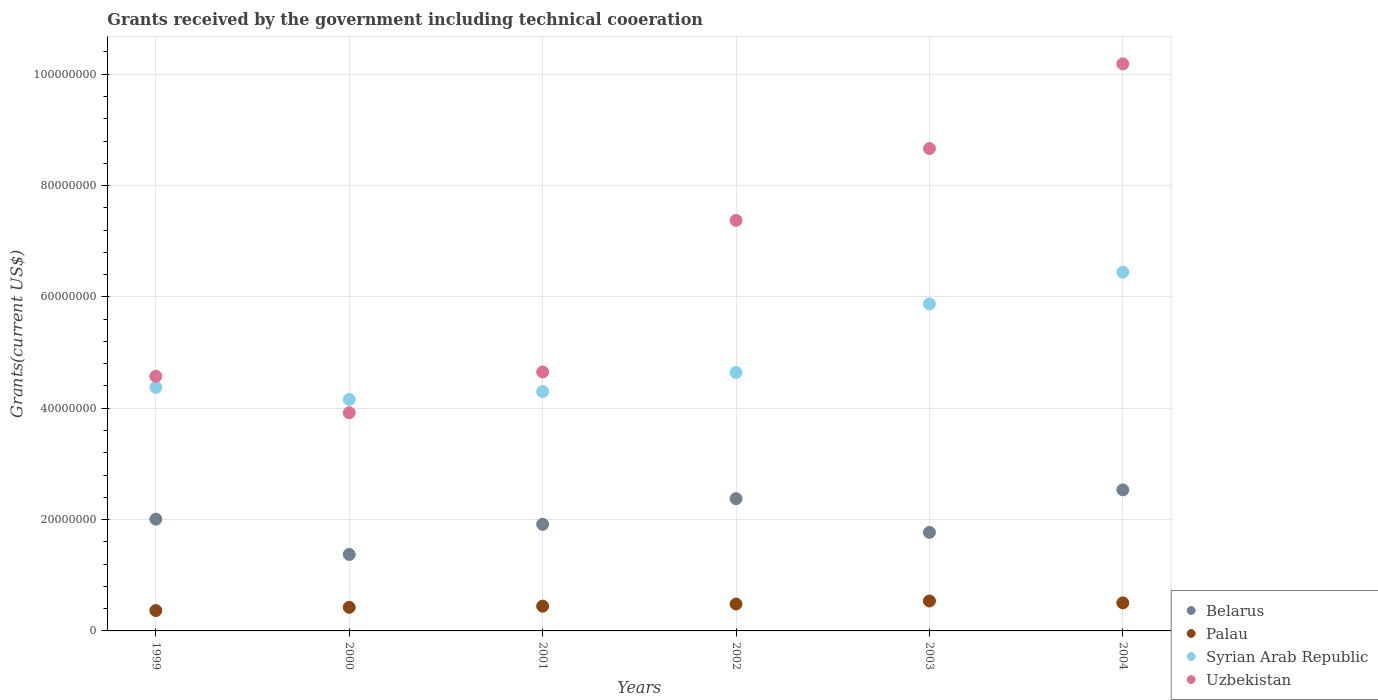How many different coloured dotlines are there?
Offer a terse response. 4. Is the number of dotlines equal to the number of legend labels?
Keep it short and to the point. Yes. What is the total grants received by the government in Belarus in 2003?
Offer a very short reply. 1.77e+07. Across all years, what is the maximum total grants received by the government in Palau?
Ensure brevity in your answer.  5.38e+06. Across all years, what is the minimum total grants received by the government in Syrian Arab Republic?
Provide a succinct answer. 4.16e+07. In which year was the total grants received by the government in Uzbekistan maximum?
Offer a terse response. 2004. In which year was the total grants received by the government in Syrian Arab Republic minimum?
Make the answer very short. 2000. What is the total total grants received by the government in Belarus in the graph?
Offer a terse response. 1.20e+08. What is the difference between the total grants received by the government in Syrian Arab Republic in 1999 and that in 2001?
Keep it short and to the point. 7.60e+05. What is the difference between the total grants received by the government in Syrian Arab Republic in 2003 and the total grants received by the government in Uzbekistan in 1999?
Your answer should be compact. 1.30e+07. What is the average total grants received by the government in Palau per year?
Your answer should be very brief. 4.60e+06. In the year 2001, what is the difference between the total grants received by the government in Belarus and total grants received by the government in Syrian Arab Republic?
Your answer should be very brief. -2.38e+07. In how many years, is the total grants received by the government in Belarus greater than 92000000 US$?
Your answer should be very brief. 0. What is the ratio of the total grants received by the government in Uzbekistan in 2001 to that in 2004?
Offer a terse response. 0.46. Is the total grants received by the government in Syrian Arab Republic in 2001 less than that in 2004?
Give a very brief answer. Yes. What is the difference between the highest and the lowest total grants received by the government in Uzbekistan?
Give a very brief answer. 6.27e+07. In how many years, is the total grants received by the government in Palau greater than the average total grants received by the government in Palau taken over all years?
Your answer should be compact. 3. Is the sum of the total grants received by the government in Belarus in 2001 and 2003 greater than the maximum total grants received by the government in Syrian Arab Republic across all years?
Your response must be concise. No. Is it the case that in every year, the sum of the total grants received by the government in Palau and total grants received by the government in Uzbekistan  is greater than the sum of total grants received by the government in Belarus and total grants received by the government in Syrian Arab Republic?
Keep it short and to the point. No. Is it the case that in every year, the sum of the total grants received by the government in Palau and total grants received by the government in Uzbekistan  is greater than the total grants received by the government in Belarus?
Your response must be concise. Yes. Does the total grants received by the government in Syrian Arab Republic monotonically increase over the years?
Make the answer very short. No. Is the total grants received by the government in Uzbekistan strictly less than the total grants received by the government in Palau over the years?
Ensure brevity in your answer.  No. What is the difference between two consecutive major ticks on the Y-axis?
Make the answer very short. 2.00e+07. Does the graph contain grids?
Make the answer very short. Yes. How many legend labels are there?
Give a very brief answer. 4. How are the legend labels stacked?
Provide a short and direct response. Vertical. What is the title of the graph?
Offer a very short reply. Grants received by the government including technical cooeration. What is the label or title of the Y-axis?
Your response must be concise. Grants(current US$). What is the Grants(current US$) in Belarus in 1999?
Give a very brief answer. 2.01e+07. What is the Grants(current US$) of Palau in 1999?
Offer a very short reply. 3.66e+06. What is the Grants(current US$) of Syrian Arab Republic in 1999?
Offer a terse response. 4.38e+07. What is the Grants(current US$) in Uzbekistan in 1999?
Provide a short and direct response. 4.57e+07. What is the Grants(current US$) of Belarus in 2000?
Make the answer very short. 1.37e+07. What is the Grants(current US$) in Palau in 2000?
Offer a terse response. 4.24e+06. What is the Grants(current US$) of Syrian Arab Republic in 2000?
Give a very brief answer. 4.16e+07. What is the Grants(current US$) of Uzbekistan in 2000?
Provide a short and direct response. 3.92e+07. What is the Grants(current US$) in Belarus in 2001?
Offer a very short reply. 1.92e+07. What is the Grants(current US$) in Palau in 2001?
Offer a very short reply. 4.45e+06. What is the Grants(current US$) in Syrian Arab Republic in 2001?
Provide a succinct answer. 4.30e+07. What is the Grants(current US$) in Uzbekistan in 2001?
Ensure brevity in your answer.  4.65e+07. What is the Grants(current US$) of Belarus in 2002?
Offer a terse response. 2.38e+07. What is the Grants(current US$) of Palau in 2002?
Provide a short and direct response. 4.83e+06. What is the Grants(current US$) of Syrian Arab Republic in 2002?
Offer a very short reply. 4.64e+07. What is the Grants(current US$) in Uzbekistan in 2002?
Your response must be concise. 7.38e+07. What is the Grants(current US$) in Belarus in 2003?
Keep it short and to the point. 1.77e+07. What is the Grants(current US$) of Palau in 2003?
Give a very brief answer. 5.38e+06. What is the Grants(current US$) of Syrian Arab Republic in 2003?
Ensure brevity in your answer.  5.87e+07. What is the Grants(current US$) of Uzbekistan in 2003?
Provide a short and direct response. 8.66e+07. What is the Grants(current US$) in Belarus in 2004?
Your answer should be very brief. 2.53e+07. What is the Grants(current US$) of Palau in 2004?
Your answer should be very brief. 5.04e+06. What is the Grants(current US$) in Syrian Arab Republic in 2004?
Your response must be concise. 6.44e+07. What is the Grants(current US$) of Uzbekistan in 2004?
Your answer should be very brief. 1.02e+08. Across all years, what is the maximum Grants(current US$) in Belarus?
Give a very brief answer. 2.53e+07. Across all years, what is the maximum Grants(current US$) of Palau?
Make the answer very short. 5.38e+06. Across all years, what is the maximum Grants(current US$) in Syrian Arab Republic?
Your response must be concise. 6.44e+07. Across all years, what is the maximum Grants(current US$) in Uzbekistan?
Provide a short and direct response. 1.02e+08. Across all years, what is the minimum Grants(current US$) of Belarus?
Offer a terse response. 1.37e+07. Across all years, what is the minimum Grants(current US$) of Palau?
Give a very brief answer. 3.66e+06. Across all years, what is the minimum Grants(current US$) of Syrian Arab Republic?
Offer a terse response. 4.16e+07. Across all years, what is the minimum Grants(current US$) of Uzbekistan?
Offer a very short reply. 3.92e+07. What is the total Grants(current US$) in Belarus in the graph?
Your response must be concise. 1.20e+08. What is the total Grants(current US$) of Palau in the graph?
Keep it short and to the point. 2.76e+07. What is the total Grants(current US$) in Syrian Arab Republic in the graph?
Offer a terse response. 2.98e+08. What is the total Grants(current US$) in Uzbekistan in the graph?
Give a very brief answer. 3.94e+08. What is the difference between the Grants(current US$) of Belarus in 1999 and that in 2000?
Give a very brief answer. 6.34e+06. What is the difference between the Grants(current US$) of Palau in 1999 and that in 2000?
Your answer should be very brief. -5.80e+05. What is the difference between the Grants(current US$) in Syrian Arab Republic in 1999 and that in 2000?
Provide a short and direct response. 2.17e+06. What is the difference between the Grants(current US$) in Uzbekistan in 1999 and that in 2000?
Give a very brief answer. 6.55e+06. What is the difference between the Grants(current US$) in Belarus in 1999 and that in 2001?
Keep it short and to the point. 9.30e+05. What is the difference between the Grants(current US$) of Palau in 1999 and that in 2001?
Your response must be concise. -7.90e+05. What is the difference between the Grants(current US$) of Syrian Arab Republic in 1999 and that in 2001?
Your answer should be very brief. 7.60e+05. What is the difference between the Grants(current US$) of Uzbekistan in 1999 and that in 2001?
Your answer should be very brief. -7.80e+05. What is the difference between the Grants(current US$) of Belarus in 1999 and that in 2002?
Your response must be concise. -3.68e+06. What is the difference between the Grants(current US$) in Palau in 1999 and that in 2002?
Provide a short and direct response. -1.17e+06. What is the difference between the Grants(current US$) of Syrian Arab Republic in 1999 and that in 2002?
Offer a terse response. -2.66e+06. What is the difference between the Grants(current US$) of Uzbekistan in 1999 and that in 2002?
Your answer should be very brief. -2.80e+07. What is the difference between the Grants(current US$) in Belarus in 1999 and that in 2003?
Offer a terse response. 2.38e+06. What is the difference between the Grants(current US$) of Palau in 1999 and that in 2003?
Offer a terse response. -1.72e+06. What is the difference between the Grants(current US$) of Syrian Arab Republic in 1999 and that in 2003?
Give a very brief answer. -1.50e+07. What is the difference between the Grants(current US$) of Uzbekistan in 1999 and that in 2003?
Your answer should be very brief. -4.09e+07. What is the difference between the Grants(current US$) in Belarus in 1999 and that in 2004?
Offer a terse response. -5.26e+06. What is the difference between the Grants(current US$) of Palau in 1999 and that in 2004?
Keep it short and to the point. -1.38e+06. What is the difference between the Grants(current US$) in Syrian Arab Republic in 1999 and that in 2004?
Your response must be concise. -2.07e+07. What is the difference between the Grants(current US$) of Uzbekistan in 1999 and that in 2004?
Make the answer very short. -5.61e+07. What is the difference between the Grants(current US$) in Belarus in 2000 and that in 2001?
Ensure brevity in your answer.  -5.41e+06. What is the difference between the Grants(current US$) in Syrian Arab Republic in 2000 and that in 2001?
Ensure brevity in your answer.  -1.41e+06. What is the difference between the Grants(current US$) in Uzbekistan in 2000 and that in 2001?
Provide a short and direct response. -7.33e+06. What is the difference between the Grants(current US$) in Belarus in 2000 and that in 2002?
Keep it short and to the point. -1.00e+07. What is the difference between the Grants(current US$) in Palau in 2000 and that in 2002?
Provide a short and direct response. -5.90e+05. What is the difference between the Grants(current US$) in Syrian Arab Republic in 2000 and that in 2002?
Keep it short and to the point. -4.83e+06. What is the difference between the Grants(current US$) in Uzbekistan in 2000 and that in 2002?
Make the answer very short. -3.46e+07. What is the difference between the Grants(current US$) in Belarus in 2000 and that in 2003?
Offer a terse response. -3.96e+06. What is the difference between the Grants(current US$) in Palau in 2000 and that in 2003?
Make the answer very short. -1.14e+06. What is the difference between the Grants(current US$) of Syrian Arab Republic in 2000 and that in 2003?
Your answer should be compact. -1.72e+07. What is the difference between the Grants(current US$) in Uzbekistan in 2000 and that in 2003?
Offer a terse response. -4.75e+07. What is the difference between the Grants(current US$) in Belarus in 2000 and that in 2004?
Provide a succinct answer. -1.16e+07. What is the difference between the Grants(current US$) of Palau in 2000 and that in 2004?
Offer a very short reply. -8.00e+05. What is the difference between the Grants(current US$) of Syrian Arab Republic in 2000 and that in 2004?
Offer a terse response. -2.28e+07. What is the difference between the Grants(current US$) in Uzbekistan in 2000 and that in 2004?
Offer a terse response. -6.27e+07. What is the difference between the Grants(current US$) in Belarus in 2001 and that in 2002?
Make the answer very short. -4.61e+06. What is the difference between the Grants(current US$) in Palau in 2001 and that in 2002?
Offer a terse response. -3.80e+05. What is the difference between the Grants(current US$) in Syrian Arab Republic in 2001 and that in 2002?
Make the answer very short. -3.42e+06. What is the difference between the Grants(current US$) in Uzbekistan in 2001 and that in 2002?
Offer a terse response. -2.72e+07. What is the difference between the Grants(current US$) in Belarus in 2001 and that in 2003?
Your response must be concise. 1.45e+06. What is the difference between the Grants(current US$) of Palau in 2001 and that in 2003?
Provide a short and direct response. -9.30e+05. What is the difference between the Grants(current US$) in Syrian Arab Republic in 2001 and that in 2003?
Your answer should be very brief. -1.57e+07. What is the difference between the Grants(current US$) in Uzbekistan in 2001 and that in 2003?
Ensure brevity in your answer.  -4.01e+07. What is the difference between the Grants(current US$) of Belarus in 2001 and that in 2004?
Your answer should be very brief. -6.19e+06. What is the difference between the Grants(current US$) of Palau in 2001 and that in 2004?
Provide a succinct answer. -5.90e+05. What is the difference between the Grants(current US$) of Syrian Arab Republic in 2001 and that in 2004?
Give a very brief answer. -2.14e+07. What is the difference between the Grants(current US$) in Uzbekistan in 2001 and that in 2004?
Provide a short and direct response. -5.53e+07. What is the difference between the Grants(current US$) in Belarus in 2002 and that in 2003?
Keep it short and to the point. 6.06e+06. What is the difference between the Grants(current US$) in Palau in 2002 and that in 2003?
Provide a succinct answer. -5.50e+05. What is the difference between the Grants(current US$) in Syrian Arab Republic in 2002 and that in 2003?
Make the answer very short. -1.23e+07. What is the difference between the Grants(current US$) of Uzbekistan in 2002 and that in 2003?
Provide a succinct answer. -1.29e+07. What is the difference between the Grants(current US$) in Belarus in 2002 and that in 2004?
Your answer should be very brief. -1.58e+06. What is the difference between the Grants(current US$) of Syrian Arab Republic in 2002 and that in 2004?
Provide a succinct answer. -1.80e+07. What is the difference between the Grants(current US$) in Uzbekistan in 2002 and that in 2004?
Make the answer very short. -2.81e+07. What is the difference between the Grants(current US$) of Belarus in 2003 and that in 2004?
Provide a succinct answer. -7.64e+06. What is the difference between the Grants(current US$) in Palau in 2003 and that in 2004?
Keep it short and to the point. 3.40e+05. What is the difference between the Grants(current US$) in Syrian Arab Republic in 2003 and that in 2004?
Provide a short and direct response. -5.70e+06. What is the difference between the Grants(current US$) in Uzbekistan in 2003 and that in 2004?
Your response must be concise. -1.52e+07. What is the difference between the Grants(current US$) in Belarus in 1999 and the Grants(current US$) in Palau in 2000?
Offer a very short reply. 1.58e+07. What is the difference between the Grants(current US$) in Belarus in 1999 and the Grants(current US$) in Syrian Arab Republic in 2000?
Offer a terse response. -2.15e+07. What is the difference between the Grants(current US$) of Belarus in 1999 and the Grants(current US$) of Uzbekistan in 2000?
Ensure brevity in your answer.  -1.91e+07. What is the difference between the Grants(current US$) in Palau in 1999 and the Grants(current US$) in Syrian Arab Republic in 2000?
Provide a succinct answer. -3.79e+07. What is the difference between the Grants(current US$) in Palau in 1999 and the Grants(current US$) in Uzbekistan in 2000?
Provide a succinct answer. -3.55e+07. What is the difference between the Grants(current US$) of Syrian Arab Republic in 1999 and the Grants(current US$) of Uzbekistan in 2000?
Your answer should be very brief. 4.57e+06. What is the difference between the Grants(current US$) of Belarus in 1999 and the Grants(current US$) of Palau in 2001?
Your response must be concise. 1.56e+07. What is the difference between the Grants(current US$) of Belarus in 1999 and the Grants(current US$) of Syrian Arab Republic in 2001?
Keep it short and to the point. -2.29e+07. What is the difference between the Grants(current US$) in Belarus in 1999 and the Grants(current US$) in Uzbekistan in 2001?
Give a very brief answer. -2.64e+07. What is the difference between the Grants(current US$) in Palau in 1999 and the Grants(current US$) in Syrian Arab Republic in 2001?
Offer a terse response. -3.93e+07. What is the difference between the Grants(current US$) of Palau in 1999 and the Grants(current US$) of Uzbekistan in 2001?
Give a very brief answer. -4.29e+07. What is the difference between the Grants(current US$) of Syrian Arab Republic in 1999 and the Grants(current US$) of Uzbekistan in 2001?
Your response must be concise. -2.76e+06. What is the difference between the Grants(current US$) of Belarus in 1999 and the Grants(current US$) of Palau in 2002?
Make the answer very short. 1.52e+07. What is the difference between the Grants(current US$) of Belarus in 1999 and the Grants(current US$) of Syrian Arab Republic in 2002?
Ensure brevity in your answer.  -2.63e+07. What is the difference between the Grants(current US$) of Belarus in 1999 and the Grants(current US$) of Uzbekistan in 2002?
Provide a succinct answer. -5.37e+07. What is the difference between the Grants(current US$) of Palau in 1999 and the Grants(current US$) of Syrian Arab Republic in 2002?
Keep it short and to the point. -4.28e+07. What is the difference between the Grants(current US$) in Palau in 1999 and the Grants(current US$) in Uzbekistan in 2002?
Provide a short and direct response. -7.01e+07. What is the difference between the Grants(current US$) of Syrian Arab Republic in 1999 and the Grants(current US$) of Uzbekistan in 2002?
Provide a short and direct response. -3.00e+07. What is the difference between the Grants(current US$) in Belarus in 1999 and the Grants(current US$) in Palau in 2003?
Your answer should be very brief. 1.47e+07. What is the difference between the Grants(current US$) of Belarus in 1999 and the Grants(current US$) of Syrian Arab Republic in 2003?
Ensure brevity in your answer.  -3.87e+07. What is the difference between the Grants(current US$) of Belarus in 1999 and the Grants(current US$) of Uzbekistan in 2003?
Ensure brevity in your answer.  -6.66e+07. What is the difference between the Grants(current US$) in Palau in 1999 and the Grants(current US$) in Syrian Arab Republic in 2003?
Make the answer very short. -5.51e+07. What is the difference between the Grants(current US$) in Palau in 1999 and the Grants(current US$) in Uzbekistan in 2003?
Keep it short and to the point. -8.30e+07. What is the difference between the Grants(current US$) of Syrian Arab Republic in 1999 and the Grants(current US$) of Uzbekistan in 2003?
Keep it short and to the point. -4.29e+07. What is the difference between the Grants(current US$) of Belarus in 1999 and the Grants(current US$) of Palau in 2004?
Offer a terse response. 1.50e+07. What is the difference between the Grants(current US$) of Belarus in 1999 and the Grants(current US$) of Syrian Arab Republic in 2004?
Ensure brevity in your answer.  -4.44e+07. What is the difference between the Grants(current US$) in Belarus in 1999 and the Grants(current US$) in Uzbekistan in 2004?
Offer a very short reply. -8.18e+07. What is the difference between the Grants(current US$) of Palau in 1999 and the Grants(current US$) of Syrian Arab Republic in 2004?
Your answer should be compact. -6.08e+07. What is the difference between the Grants(current US$) in Palau in 1999 and the Grants(current US$) in Uzbekistan in 2004?
Your answer should be very brief. -9.82e+07. What is the difference between the Grants(current US$) of Syrian Arab Republic in 1999 and the Grants(current US$) of Uzbekistan in 2004?
Make the answer very short. -5.81e+07. What is the difference between the Grants(current US$) of Belarus in 2000 and the Grants(current US$) of Palau in 2001?
Keep it short and to the point. 9.29e+06. What is the difference between the Grants(current US$) of Belarus in 2000 and the Grants(current US$) of Syrian Arab Republic in 2001?
Offer a terse response. -2.93e+07. What is the difference between the Grants(current US$) in Belarus in 2000 and the Grants(current US$) in Uzbekistan in 2001?
Keep it short and to the point. -3.28e+07. What is the difference between the Grants(current US$) of Palau in 2000 and the Grants(current US$) of Syrian Arab Republic in 2001?
Your answer should be very brief. -3.88e+07. What is the difference between the Grants(current US$) of Palau in 2000 and the Grants(current US$) of Uzbekistan in 2001?
Ensure brevity in your answer.  -4.23e+07. What is the difference between the Grants(current US$) of Syrian Arab Republic in 2000 and the Grants(current US$) of Uzbekistan in 2001?
Ensure brevity in your answer.  -4.93e+06. What is the difference between the Grants(current US$) of Belarus in 2000 and the Grants(current US$) of Palau in 2002?
Provide a succinct answer. 8.91e+06. What is the difference between the Grants(current US$) in Belarus in 2000 and the Grants(current US$) in Syrian Arab Republic in 2002?
Provide a short and direct response. -3.27e+07. What is the difference between the Grants(current US$) of Belarus in 2000 and the Grants(current US$) of Uzbekistan in 2002?
Provide a succinct answer. -6.00e+07. What is the difference between the Grants(current US$) of Palau in 2000 and the Grants(current US$) of Syrian Arab Republic in 2002?
Your response must be concise. -4.22e+07. What is the difference between the Grants(current US$) of Palau in 2000 and the Grants(current US$) of Uzbekistan in 2002?
Ensure brevity in your answer.  -6.95e+07. What is the difference between the Grants(current US$) in Syrian Arab Republic in 2000 and the Grants(current US$) in Uzbekistan in 2002?
Keep it short and to the point. -3.22e+07. What is the difference between the Grants(current US$) of Belarus in 2000 and the Grants(current US$) of Palau in 2003?
Give a very brief answer. 8.36e+06. What is the difference between the Grants(current US$) of Belarus in 2000 and the Grants(current US$) of Syrian Arab Republic in 2003?
Keep it short and to the point. -4.50e+07. What is the difference between the Grants(current US$) of Belarus in 2000 and the Grants(current US$) of Uzbekistan in 2003?
Make the answer very short. -7.29e+07. What is the difference between the Grants(current US$) in Palau in 2000 and the Grants(current US$) in Syrian Arab Republic in 2003?
Keep it short and to the point. -5.45e+07. What is the difference between the Grants(current US$) of Palau in 2000 and the Grants(current US$) of Uzbekistan in 2003?
Your response must be concise. -8.24e+07. What is the difference between the Grants(current US$) of Syrian Arab Republic in 2000 and the Grants(current US$) of Uzbekistan in 2003?
Provide a succinct answer. -4.51e+07. What is the difference between the Grants(current US$) in Belarus in 2000 and the Grants(current US$) in Palau in 2004?
Make the answer very short. 8.70e+06. What is the difference between the Grants(current US$) of Belarus in 2000 and the Grants(current US$) of Syrian Arab Republic in 2004?
Give a very brief answer. -5.07e+07. What is the difference between the Grants(current US$) of Belarus in 2000 and the Grants(current US$) of Uzbekistan in 2004?
Offer a terse response. -8.81e+07. What is the difference between the Grants(current US$) of Palau in 2000 and the Grants(current US$) of Syrian Arab Republic in 2004?
Give a very brief answer. -6.02e+07. What is the difference between the Grants(current US$) of Palau in 2000 and the Grants(current US$) of Uzbekistan in 2004?
Your answer should be very brief. -9.76e+07. What is the difference between the Grants(current US$) of Syrian Arab Republic in 2000 and the Grants(current US$) of Uzbekistan in 2004?
Keep it short and to the point. -6.03e+07. What is the difference between the Grants(current US$) in Belarus in 2001 and the Grants(current US$) in Palau in 2002?
Keep it short and to the point. 1.43e+07. What is the difference between the Grants(current US$) of Belarus in 2001 and the Grants(current US$) of Syrian Arab Republic in 2002?
Keep it short and to the point. -2.73e+07. What is the difference between the Grants(current US$) of Belarus in 2001 and the Grants(current US$) of Uzbekistan in 2002?
Your answer should be very brief. -5.46e+07. What is the difference between the Grants(current US$) in Palau in 2001 and the Grants(current US$) in Syrian Arab Republic in 2002?
Make the answer very short. -4.20e+07. What is the difference between the Grants(current US$) of Palau in 2001 and the Grants(current US$) of Uzbekistan in 2002?
Ensure brevity in your answer.  -6.93e+07. What is the difference between the Grants(current US$) in Syrian Arab Republic in 2001 and the Grants(current US$) in Uzbekistan in 2002?
Give a very brief answer. -3.08e+07. What is the difference between the Grants(current US$) of Belarus in 2001 and the Grants(current US$) of Palau in 2003?
Give a very brief answer. 1.38e+07. What is the difference between the Grants(current US$) of Belarus in 2001 and the Grants(current US$) of Syrian Arab Republic in 2003?
Your response must be concise. -3.96e+07. What is the difference between the Grants(current US$) in Belarus in 2001 and the Grants(current US$) in Uzbekistan in 2003?
Give a very brief answer. -6.75e+07. What is the difference between the Grants(current US$) in Palau in 2001 and the Grants(current US$) in Syrian Arab Republic in 2003?
Your answer should be very brief. -5.43e+07. What is the difference between the Grants(current US$) in Palau in 2001 and the Grants(current US$) in Uzbekistan in 2003?
Give a very brief answer. -8.22e+07. What is the difference between the Grants(current US$) of Syrian Arab Republic in 2001 and the Grants(current US$) of Uzbekistan in 2003?
Ensure brevity in your answer.  -4.36e+07. What is the difference between the Grants(current US$) in Belarus in 2001 and the Grants(current US$) in Palau in 2004?
Offer a very short reply. 1.41e+07. What is the difference between the Grants(current US$) in Belarus in 2001 and the Grants(current US$) in Syrian Arab Republic in 2004?
Provide a succinct answer. -4.53e+07. What is the difference between the Grants(current US$) in Belarus in 2001 and the Grants(current US$) in Uzbekistan in 2004?
Keep it short and to the point. -8.27e+07. What is the difference between the Grants(current US$) in Palau in 2001 and the Grants(current US$) in Syrian Arab Republic in 2004?
Your answer should be very brief. -6.00e+07. What is the difference between the Grants(current US$) of Palau in 2001 and the Grants(current US$) of Uzbekistan in 2004?
Your response must be concise. -9.74e+07. What is the difference between the Grants(current US$) in Syrian Arab Republic in 2001 and the Grants(current US$) in Uzbekistan in 2004?
Your answer should be compact. -5.89e+07. What is the difference between the Grants(current US$) of Belarus in 2002 and the Grants(current US$) of Palau in 2003?
Give a very brief answer. 1.84e+07. What is the difference between the Grants(current US$) in Belarus in 2002 and the Grants(current US$) in Syrian Arab Republic in 2003?
Ensure brevity in your answer.  -3.50e+07. What is the difference between the Grants(current US$) in Belarus in 2002 and the Grants(current US$) in Uzbekistan in 2003?
Your answer should be very brief. -6.29e+07. What is the difference between the Grants(current US$) in Palau in 2002 and the Grants(current US$) in Syrian Arab Republic in 2003?
Keep it short and to the point. -5.39e+07. What is the difference between the Grants(current US$) of Palau in 2002 and the Grants(current US$) of Uzbekistan in 2003?
Your response must be concise. -8.18e+07. What is the difference between the Grants(current US$) of Syrian Arab Republic in 2002 and the Grants(current US$) of Uzbekistan in 2003?
Offer a very short reply. -4.02e+07. What is the difference between the Grants(current US$) in Belarus in 2002 and the Grants(current US$) in Palau in 2004?
Offer a very short reply. 1.87e+07. What is the difference between the Grants(current US$) in Belarus in 2002 and the Grants(current US$) in Syrian Arab Republic in 2004?
Keep it short and to the point. -4.07e+07. What is the difference between the Grants(current US$) in Belarus in 2002 and the Grants(current US$) in Uzbekistan in 2004?
Provide a succinct answer. -7.81e+07. What is the difference between the Grants(current US$) of Palau in 2002 and the Grants(current US$) of Syrian Arab Republic in 2004?
Offer a terse response. -5.96e+07. What is the difference between the Grants(current US$) of Palau in 2002 and the Grants(current US$) of Uzbekistan in 2004?
Offer a terse response. -9.70e+07. What is the difference between the Grants(current US$) in Syrian Arab Republic in 2002 and the Grants(current US$) in Uzbekistan in 2004?
Offer a terse response. -5.54e+07. What is the difference between the Grants(current US$) in Belarus in 2003 and the Grants(current US$) in Palau in 2004?
Your answer should be compact. 1.27e+07. What is the difference between the Grants(current US$) of Belarus in 2003 and the Grants(current US$) of Syrian Arab Republic in 2004?
Make the answer very short. -4.67e+07. What is the difference between the Grants(current US$) in Belarus in 2003 and the Grants(current US$) in Uzbekistan in 2004?
Provide a succinct answer. -8.42e+07. What is the difference between the Grants(current US$) in Palau in 2003 and the Grants(current US$) in Syrian Arab Republic in 2004?
Keep it short and to the point. -5.91e+07. What is the difference between the Grants(current US$) of Palau in 2003 and the Grants(current US$) of Uzbekistan in 2004?
Ensure brevity in your answer.  -9.65e+07. What is the difference between the Grants(current US$) of Syrian Arab Republic in 2003 and the Grants(current US$) of Uzbekistan in 2004?
Provide a short and direct response. -4.31e+07. What is the average Grants(current US$) in Belarus per year?
Provide a succinct answer. 2.00e+07. What is the average Grants(current US$) of Palau per year?
Give a very brief answer. 4.60e+06. What is the average Grants(current US$) in Syrian Arab Republic per year?
Keep it short and to the point. 4.97e+07. What is the average Grants(current US$) in Uzbekistan per year?
Provide a short and direct response. 6.56e+07. In the year 1999, what is the difference between the Grants(current US$) in Belarus and Grants(current US$) in Palau?
Offer a very short reply. 1.64e+07. In the year 1999, what is the difference between the Grants(current US$) of Belarus and Grants(current US$) of Syrian Arab Republic?
Make the answer very short. -2.37e+07. In the year 1999, what is the difference between the Grants(current US$) in Belarus and Grants(current US$) in Uzbekistan?
Your answer should be compact. -2.57e+07. In the year 1999, what is the difference between the Grants(current US$) in Palau and Grants(current US$) in Syrian Arab Republic?
Ensure brevity in your answer.  -4.01e+07. In the year 1999, what is the difference between the Grants(current US$) in Palau and Grants(current US$) in Uzbekistan?
Provide a succinct answer. -4.21e+07. In the year 1999, what is the difference between the Grants(current US$) in Syrian Arab Republic and Grants(current US$) in Uzbekistan?
Provide a succinct answer. -1.98e+06. In the year 2000, what is the difference between the Grants(current US$) in Belarus and Grants(current US$) in Palau?
Offer a terse response. 9.50e+06. In the year 2000, what is the difference between the Grants(current US$) in Belarus and Grants(current US$) in Syrian Arab Republic?
Your response must be concise. -2.78e+07. In the year 2000, what is the difference between the Grants(current US$) of Belarus and Grants(current US$) of Uzbekistan?
Your answer should be compact. -2.54e+07. In the year 2000, what is the difference between the Grants(current US$) in Palau and Grants(current US$) in Syrian Arab Republic?
Provide a short and direct response. -3.74e+07. In the year 2000, what is the difference between the Grants(current US$) in Palau and Grants(current US$) in Uzbekistan?
Make the answer very short. -3.50e+07. In the year 2000, what is the difference between the Grants(current US$) in Syrian Arab Republic and Grants(current US$) in Uzbekistan?
Offer a very short reply. 2.40e+06. In the year 2001, what is the difference between the Grants(current US$) of Belarus and Grants(current US$) of Palau?
Offer a very short reply. 1.47e+07. In the year 2001, what is the difference between the Grants(current US$) in Belarus and Grants(current US$) in Syrian Arab Republic?
Your answer should be compact. -2.38e+07. In the year 2001, what is the difference between the Grants(current US$) of Belarus and Grants(current US$) of Uzbekistan?
Provide a short and direct response. -2.74e+07. In the year 2001, what is the difference between the Grants(current US$) of Palau and Grants(current US$) of Syrian Arab Republic?
Provide a succinct answer. -3.86e+07. In the year 2001, what is the difference between the Grants(current US$) in Palau and Grants(current US$) in Uzbekistan?
Keep it short and to the point. -4.21e+07. In the year 2001, what is the difference between the Grants(current US$) in Syrian Arab Republic and Grants(current US$) in Uzbekistan?
Give a very brief answer. -3.52e+06. In the year 2002, what is the difference between the Grants(current US$) of Belarus and Grants(current US$) of Palau?
Ensure brevity in your answer.  1.89e+07. In the year 2002, what is the difference between the Grants(current US$) in Belarus and Grants(current US$) in Syrian Arab Republic?
Ensure brevity in your answer.  -2.27e+07. In the year 2002, what is the difference between the Grants(current US$) of Belarus and Grants(current US$) of Uzbekistan?
Provide a short and direct response. -5.00e+07. In the year 2002, what is the difference between the Grants(current US$) of Palau and Grants(current US$) of Syrian Arab Republic?
Make the answer very short. -4.16e+07. In the year 2002, what is the difference between the Grants(current US$) in Palau and Grants(current US$) in Uzbekistan?
Provide a short and direct response. -6.89e+07. In the year 2002, what is the difference between the Grants(current US$) of Syrian Arab Republic and Grants(current US$) of Uzbekistan?
Provide a short and direct response. -2.73e+07. In the year 2003, what is the difference between the Grants(current US$) of Belarus and Grants(current US$) of Palau?
Your response must be concise. 1.23e+07. In the year 2003, what is the difference between the Grants(current US$) in Belarus and Grants(current US$) in Syrian Arab Republic?
Your answer should be very brief. -4.10e+07. In the year 2003, what is the difference between the Grants(current US$) of Belarus and Grants(current US$) of Uzbekistan?
Your answer should be very brief. -6.90e+07. In the year 2003, what is the difference between the Grants(current US$) in Palau and Grants(current US$) in Syrian Arab Republic?
Offer a terse response. -5.34e+07. In the year 2003, what is the difference between the Grants(current US$) of Palau and Grants(current US$) of Uzbekistan?
Provide a succinct answer. -8.13e+07. In the year 2003, what is the difference between the Grants(current US$) of Syrian Arab Republic and Grants(current US$) of Uzbekistan?
Ensure brevity in your answer.  -2.79e+07. In the year 2004, what is the difference between the Grants(current US$) in Belarus and Grants(current US$) in Palau?
Provide a short and direct response. 2.03e+07. In the year 2004, what is the difference between the Grants(current US$) of Belarus and Grants(current US$) of Syrian Arab Republic?
Your answer should be very brief. -3.91e+07. In the year 2004, what is the difference between the Grants(current US$) of Belarus and Grants(current US$) of Uzbekistan?
Your answer should be compact. -7.65e+07. In the year 2004, what is the difference between the Grants(current US$) of Palau and Grants(current US$) of Syrian Arab Republic?
Ensure brevity in your answer.  -5.94e+07. In the year 2004, what is the difference between the Grants(current US$) in Palau and Grants(current US$) in Uzbekistan?
Your answer should be compact. -9.68e+07. In the year 2004, what is the difference between the Grants(current US$) in Syrian Arab Republic and Grants(current US$) in Uzbekistan?
Keep it short and to the point. -3.74e+07. What is the ratio of the Grants(current US$) of Belarus in 1999 to that in 2000?
Offer a terse response. 1.46. What is the ratio of the Grants(current US$) of Palau in 1999 to that in 2000?
Your answer should be very brief. 0.86. What is the ratio of the Grants(current US$) in Syrian Arab Republic in 1999 to that in 2000?
Keep it short and to the point. 1.05. What is the ratio of the Grants(current US$) of Uzbekistan in 1999 to that in 2000?
Give a very brief answer. 1.17. What is the ratio of the Grants(current US$) of Belarus in 1999 to that in 2001?
Ensure brevity in your answer.  1.05. What is the ratio of the Grants(current US$) of Palau in 1999 to that in 2001?
Make the answer very short. 0.82. What is the ratio of the Grants(current US$) in Syrian Arab Republic in 1999 to that in 2001?
Offer a terse response. 1.02. What is the ratio of the Grants(current US$) in Uzbekistan in 1999 to that in 2001?
Your answer should be compact. 0.98. What is the ratio of the Grants(current US$) of Belarus in 1999 to that in 2002?
Give a very brief answer. 0.85. What is the ratio of the Grants(current US$) in Palau in 1999 to that in 2002?
Ensure brevity in your answer.  0.76. What is the ratio of the Grants(current US$) of Syrian Arab Republic in 1999 to that in 2002?
Your response must be concise. 0.94. What is the ratio of the Grants(current US$) in Uzbekistan in 1999 to that in 2002?
Give a very brief answer. 0.62. What is the ratio of the Grants(current US$) in Belarus in 1999 to that in 2003?
Your answer should be compact. 1.13. What is the ratio of the Grants(current US$) of Palau in 1999 to that in 2003?
Your answer should be very brief. 0.68. What is the ratio of the Grants(current US$) in Syrian Arab Republic in 1999 to that in 2003?
Your response must be concise. 0.74. What is the ratio of the Grants(current US$) of Uzbekistan in 1999 to that in 2003?
Offer a very short reply. 0.53. What is the ratio of the Grants(current US$) in Belarus in 1999 to that in 2004?
Your answer should be compact. 0.79. What is the ratio of the Grants(current US$) in Palau in 1999 to that in 2004?
Keep it short and to the point. 0.73. What is the ratio of the Grants(current US$) of Syrian Arab Republic in 1999 to that in 2004?
Your answer should be compact. 0.68. What is the ratio of the Grants(current US$) in Uzbekistan in 1999 to that in 2004?
Give a very brief answer. 0.45. What is the ratio of the Grants(current US$) of Belarus in 2000 to that in 2001?
Your answer should be very brief. 0.72. What is the ratio of the Grants(current US$) of Palau in 2000 to that in 2001?
Ensure brevity in your answer.  0.95. What is the ratio of the Grants(current US$) of Syrian Arab Republic in 2000 to that in 2001?
Make the answer very short. 0.97. What is the ratio of the Grants(current US$) in Uzbekistan in 2000 to that in 2001?
Keep it short and to the point. 0.84. What is the ratio of the Grants(current US$) in Belarus in 2000 to that in 2002?
Provide a short and direct response. 0.58. What is the ratio of the Grants(current US$) of Palau in 2000 to that in 2002?
Your answer should be very brief. 0.88. What is the ratio of the Grants(current US$) of Syrian Arab Republic in 2000 to that in 2002?
Your response must be concise. 0.9. What is the ratio of the Grants(current US$) in Uzbekistan in 2000 to that in 2002?
Make the answer very short. 0.53. What is the ratio of the Grants(current US$) in Belarus in 2000 to that in 2003?
Give a very brief answer. 0.78. What is the ratio of the Grants(current US$) of Palau in 2000 to that in 2003?
Give a very brief answer. 0.79. What is the ratio of the Grants(current US$) of Syrian Arab Republic in 2000 to that in 2003?
Give a very brief answer. 0.71. What is the ratio of the Grants(current US$) in Uzbekistan in 2000 to that in 2003?
Ensure brevity in your answer.  0.45. What is the ratio of the Grants(current US$) of Belarus in 2000 to that in 2004?
Your response must be concise. 0.54. What is the ratio of the Grants(current US$) in Palau in 2000 to that in 2004?
Provide a succinct answer. 0.84. What is the ratio of the Grants(current US$) of Syrian Arab Republic in 2000 to that in 2004?
Provide a short and direct response. 0.65. What is the ratio of the Grants(current US$) in Uzbekistan in 2000 to that in 2004?
Your answer should be compact. 0.38. What is the ratio of the Grants(current US$) of Belarus in 2001 to that in 2002?
Offer a terse response. 0.81. What is the ratio of the Grants(current US$) in Palau in 2001 to that in 2002?
Make the answer very short. 0.92. What is the ratio of the Grants(current US$) in Syrian Arab Republic in 2001 to that in 2002?
Keep it short and to the point. 0.93. What is the ratio of the Grants(current US$) in Uzbekistan in 2001 to that in 2002?
Provide a succinct answer. 0.63. What is the ratio of the Grants(current US$) of Belarus in 2001 to that in 2003?
Offer a terse response. 1.08. What is the ratio of the Grants(current US$) in Palau in 2001 to that in 2003?
Provide a short and direct response. 0.83. What is the ratio of the Grants(current US$) of Syrian Arab Republic in 2001 to that in 2003?
Offer a terse response. 0.73. What is the ratio of the Grants(current US$) in Uzbekistan in 2001 to that in 2003?
Provide a succinct answer. 0.54. What is the ratio of the Grants(current US$) in Belarus in 2001 to that in 2004?
Ensure brevity in your answer.  0.76. What is the ratio of the Grants(current US$) in Palau in 2001 to that in 2004?
Provide a short and direct response. 0.88. What is the ratio of the Grants(current US$) in Syrian Arab Republic in 2001 to that in 2004?
Ensure brevity in your answer.  0.67. What is the ratio of the Grants(current US$) in Uzbekistan in 2001 to that in 2004?
Make the answer very short. 0.46. What is the ratio of the Grants(current US$) of Belarus in 2002 to that in 2003?
Your answer should be compact. 1.34. What is the ratio of the Grants(current US$) in Palau in 2002 to that in 2003?
Offer a terse response. 0.9. What is the ratio of the Grants(current US$) in Syrian Arab Republic in 2002 to that in 2003?
Offer a terse response. 0.79. What is the ratio of the Grants(current US$) in Uzbekistan in 2002 to that in 2003?
Give a very brief answer. 0.85. What is the ratio of the Grants(current US$) of Belarus in 2002 to that in 2004?
Make the answer very short. 0.94. What is the ratio of the Grants(current US$) of Syrian Arab Republic in 2002 to that in 2004?
Provide a short and direct response. 0.72. What is the ratio of the Grants(current US$) in Uzbekistan in 2002 to that in 2004?
Your answer should be very brief. 0.72. What is the ratio of the Grants(current US$) of Belarus in 2003 to that in 2004?
Provide a short and direct response. 0.7. What is the ratio of the Grants(current US$) in Palau in 2003 to that in 2004?
Give a very brief answer. 1.07. What is the ratio of the Grants(current US$) in Syrian Arab Republic in 2003 to that in 2004?
Make the answer very short. 0.91. What is the ratio of the Grants(current US$) in Uzbekistan in 2003 to that in 2004?
Ensure brevity in your answer.  0.85. What is the difference between the highest and the second highest Grants(current US$) of Belarus?
Your answer should be compact. 1.58e+06. What is the difference between the highest and the second highest Grants(current US$) of Syrian Arab Republic?
Give a very brief answer. 5.70e+06. What is the difference between the highest and the second highest Grants(current US$) in Uzbekistan?
Keep it short and to the point. 1.52e+07. What is the difference between the highest and the lowest Grants(current US$) of Belarus?
Give a very brief answer. 1.16e+07. What is the difference between the highest and the lowest Grants(current US$) of Palau?
Offer a very short reply. 1.72e+06. What is the difference between the highest and the lowest Grants(current US$) in Syrian Arab Republic?
Keep it short and to the point. 2.28e+07. What is the difference between the highest and the lowest Grants(current US$) in Uzbekistan?
Make the answer very short. 6.27e+07. 